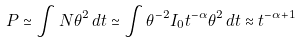<formula> <loc_0><loc_0><loc_500><loc_500>P \simeq \int N \theta ^ { 2 } \, d t \simeq \int \theta ^ { - 2 } I _ { 0 } t ^ { - \alpha } \theta ^ { 2 } \, d t \approx t ^ { - \alpha + 1 }</formula> 